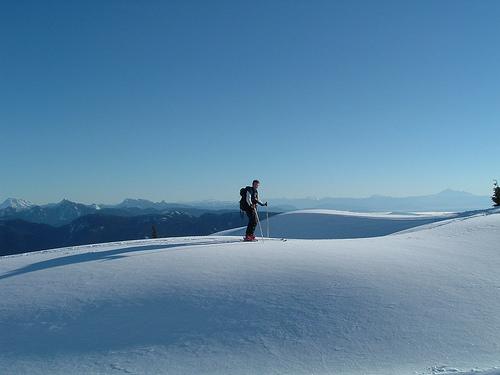What is covering the ground?
Give a very brief answer. Snow. Is the snow smooth?
Keep it brief. Yes. Is he on the skateboard?
Short answer required. No. Is the sky clear?
Be succinct. Yes. Where is the person located?
Be succinct. Mountain. Is the person trying to go down a ski slope?
Be succinct. No. Is the photo blurry?
Give a very brief answer. No. What is this person doing?
Keep it brief. Skiing. How many ski poles is the man  holding?
Be succinct. 2. How clear is the sky?
Be succinct. Very. What is the guy on?
Concise answer only. Skis. Is this a competition?
Keep it brief. No. Are there any clouds in the sky?
Quick response, please. No. Are those perfectly straight lines?
Quick response, please. No. How many trees have leaves?
Quick response, please. 0. Is there a cliff in front of the skier?
Answer briefly. No. Is he on the ground?
Give a very brief answer. Yes. How many people are riding bikes?
Answer briefly. 0. Is this a dangerous move?
Write a very short answer. No. What is seen on the sky?
Short answer required. Nothing. Is this an event?
Quick response, please. No. What does the man have on his back?
Answer briefly. Backpack. Has the ski hill been used before?
Short answer required. No. Are there paths for movement?
Give a very brief answer. No. 